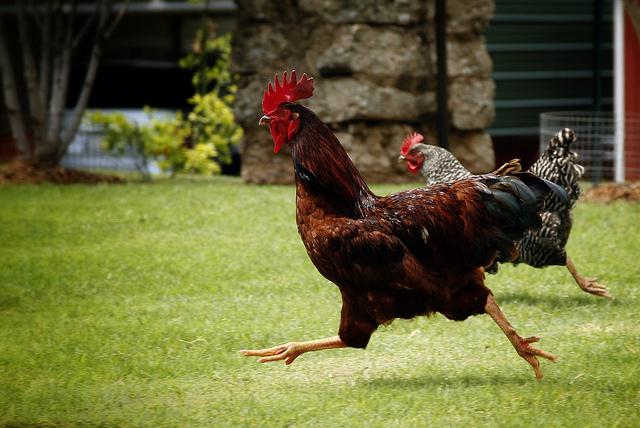What are the chickens doing?
Concise answer only. Running. How many chickens are there?
Be succinct. 2. What color is the grass?
Keep it brief. Green. 